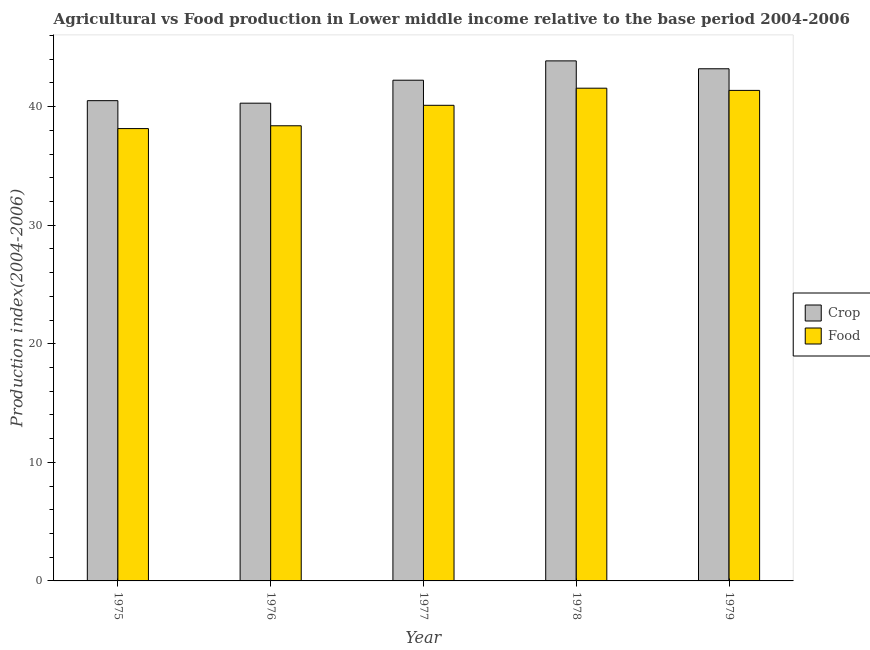How many different coloured bars are there?
Provide a short and direct response. 2. How many groups of bars are there?
Ensure brevity in your answer.  5. Are the number of bars per tick equal to the number of legend labels?
Keep it short and to the point. Yes. How many bars are there on the 1st tick from the right?
Provide a short and direct response. 2. What is the label of the 3rd group of bars from the left?
Your answer should be compact. 1977. In how many cases, is the number of bars for a given year not equal to the number of legend labels?
Keep it short and to the point. 0. What is the food production index in 1975?
Your answer should be very brief. 38.14. Across all years, what is the maximum food production index?
Your answer should be compact. 41.55. Across all years, what is the minimum crop production index?
Your response must be concise. 40.29. In which year was the crop production index maximum?
Ensure brevity in your answer.  1978. In which year was the food production index minimum?
Your answer should be compact. 1975. What is the total food production index in the graph?
Keep it short and to the point. 199.54. What is the difference between the food production index in 1975 and that in 1978?
Make the answer very short. -3.41. What is the difference between the food production index in 1979 and the crop production index in 1977?
Give a very brief answer. 1.26. What is the average food production index per year?
Ensure brevity in your answer.  39.91. In the year 1975, what is the difference between the crop production index and food production index?
Your answer should be compact. 0. In how many years, is the crop production index greater than 36?
Give a very brief answer. 5. What is the ratio of the crop production index in 1977 to that in 1979?
Keep it short and to the point. 0.98. Is the difference between the crop production index in 1975 and 1978 greater than the difference between the food production index in 1975 and 1978?
Your answer should be compact. No. What is the difference between the highest and the second highest crop production index?
Offer a terse response. 0.67. What is the difference between the highest and the lowest food production index?
Provide a short and direct response. 3.41. In how many years, is the crop production index greater than the average crop production index taken over all years?
Your answer should be very brief. 3. What does the 2nd bar from the left in 1977 represents?
Your response must be concise. Food. What does the 1st bar from the right in 1976 represents?
Offer a very short reply. Food. Does the graph contain any zero values?
Offer a terse response. No. Does the graph contain grids?
Provide a short and direct response. No. How many legend labels are there?
Provide a succinct answer. 2. How are the legend labels stacked?
Your answer should be very brief. Vertical. What is the title of the graph?
Ensure brevity in your answer.  Agricultural vs Food production in Lower middle income relative to the base period 2004-2006. Does "Diesel" appear as one of the legend labels in the graph?
Offer a very short reply. No. What is the label or title of the X-axis?
Provide a short and direct response. Year. What is the label or title of the Y-axis?
Provide a succinct answer. Production index(2004-2006). What is the Production index(2004-2006) of Crop in 1975?
Offer a very short reply. 40.5. What is the Production index(2004-2006) in Food in 1975?
Your answer should be very brief. 38.14. What is the Production index(2004-2006) of Crop in 1976?
Give a very brief answer. 40.29. What is the Production index(2004-2006) in Food in 1976?
Provide a short and direct response. 38.38. What is the Production index(2004-2006) in Crop in 1977?
Ensure brevity in your answer.  42.22. What is the Production index(2004-2006) in Food in 1977?
Your answer should be very brief. 40.11. What is the Production index(2004-2006) in Crop in 1978?
Your answer should be very brief. 43.85. What is the Production index(2004-2006) of Food in 1978?
Provide a short and direct response. 41.55. What is the Production index(2004-2006) in Crop in 1979?
Your answer should be very brief. 43.19. What is the Production index(2004-2006) of Food in 1979?
Ensure brevity in your answer.  41.36. Across all years, what is the maximum Production index(2004-2006) of Crop?
Your answer should be compact. 43.85. Across all years, what is the maximum Production index(2004-2006) in Food?
Your answer should be very brief. 41.55. Across all years, what is the minimum Production index(2004-2006) in Crop?
Provide a succinct answer. 40.29. Across all years, what is the minimum Production index(2004-2006) of Food?
Make the answer very short. 38.14. What is the total Production index(2004-2006) in Crop in the graph?
Make the answer very short. 210.05. What is the total Production index(2004-2006) in Food in the graph?
Provide a succinct answer. 199.54. What is the difference between the Production index(2004-2006) in Crop in 1975 and that in 1976?
Your answer should be compact. 0.21. What is the difference between the Production index(2004-2006) of Food in 1975 and that in 1976?
Offer a very short reply. -0.24. What is the difference between the Production index(2004-2006) of Crop in 1975 and that in 1977?
Keep it short and to the point. -1.72. What is the difference between the Production index(2004-2006) of Food in 1975 and that in 1977?
Give a very brief answer. -1.96. What is the difference between the Production index(2004-2006) of Crop in 1975 and that in 1978?
Give a very brief answer. -3.35. What is the difference between the Production index(2004-2006) of Food in 1975 and that in 1978?
Your response must be concise. -3.41. What is the difference between the Production index(2004-2006) in Crop in 1975 and that in 1979?
Your answer should be compact. -2.69. What is the difference between the Production index(2004-2006) of Food in 1975 and that in 1979?
Offer a very short reply. -3.22. What is the difference between the Production index(2004-2006) in Crop in 1976 and that in 1977?
Ensure brevity in your answer.  -1.94. What is the difference between the Production index(2004-2006) in Food in 1976 and that in 1977?
Offer a terse response. -1.73. What is the difference between the Production index(2004-2006) in Crop in 1976 and that in 1978?
Make the answer very short. -3.57. What is the difference between the Production index(2004-2006) in Food in 1976 and that in 1978?
Ensure brevity in your answer.  -3.17. What is the difference between the Production index(2004-2006) of Crop in 1976 and that in 1979?
Your response must be concise. -2.9. What is the difference between the Production index(2004-2006) of Food in 1976 and that in 1979?
Your response must be concise. -2.98. What is the difference between the Production index(2004-2006) of Crop in 1977 and that in 1978?
Provide a succinct answer. -1.63. What is the difference between the Production index(2004-2006) of Food in 1977 and that in 1978?
Ensure brevity in your answer.  -1.44. What is the difference between the Production index(2004-2006) in Crop in 1977 and that in 1979?
Give a very brief answer. -0.96. What is the difference between the Production index(2004-2006) in Food in 1977 and that in 1979?
Your answer should be compact. -1.26. What is the difference between the Production index(2004-2006) of Crop in 1978 and that in 1979?
Your answer should be very brief. 0.67. What is the difference between the Production index(2004-2006) of Food in 1978 and that in 1979?
Give a very brief answer. 0.19. What is the difference between the Production index(2004-2006) in Crop in 1975 and the Production index(2004-2006) in Food in 1976?
Make the answer very short. 2.12. What is the difference between the Production index(2004-2006) of Crop in 1975 and the Production index(2004-2006) of Food in 1977?
Offer a very short reply. 0.39. What is the difference between the Production index(2004-2006) in Crop in 1975 and the Production index(2004-2006) in Food in 1978?
Your answer should be compact. -1.05. What is the difference between the Production index(2004-2006) in Crop in 1975 and the Production index(2004-2006) in Food in 1979?
Provide a short and direct response. -0.86. What is the difference between the Production index(2004-2006) of Crop in 1976 and the Production index(2004-2006) of Food in 1977?
Offer a very short reply. 0.18. What is the difference between the Production index(2004-2006) of Crop in 1976 and the Production index(2004-2006) of Food in 1978?
Offer a terse response. -1.26. What is the difference between the Production index(2004-2006) in Crop in 1976 and the Production index(2004-2006) in Food in 1979?
Provide a short and direct response. -1.08. What is the difference between the Production index(2004-2006) of Crop in 1977 and the Production index(2004-2006) of Food in 1978?
Provide a succinct answer. 0.67. What is the difference between the Production index(2004-2006) of Crop in 1977 and the Production index(2004-2006) of Food in 1979?
Provide a short and direct response. 0.86. What is the difference between the Production index(2004-2006) in Crop in 1978 and the Production index(2004-2006) in Food in 1979?
Offer a very short reply. 2.49. What is the average Production index(2004-2006) of Crop per year?
Offer a terse response. 42.01. What is the average Production index(2004-2006) of Food per year?
Your response must be concise. 39.91. In the year 1975, what is the difference between the Production index(2004-2006) in Crop and Production index(2004-2006) in Food?
Offer a terse response. 2.35. In the year 1976, what is the difference between the Production index(2004-2006) of Crop and Production index(2004-2006) of Food?
Offer a very short reply. 1.91. In the year 1977, what is the difference between the Production index(2004-2006) of Crop and Production index(2004-2006) of Food?
Make the answer very short. 2.12. In the year 1978, what is the difference between the Production index(2004-2006) in Crop and Production index(2004-2006) in Food?
Keep it short and to the point. 2.3. In the year 1979, what is the difference between the Production index(2004-2006) in Crop and Production index(2004-2006) in Food?
Offer a very short reply. 1.82. What is the ratio of the Production index(2004-2006) in Crop in 1975 to that in 1976?
Your response must be concise. 1.01. What is the ratio of the Production index(2004-2006) of Crop in 1975 to that in 1977?
Your response must be concise. 0.96. What is the ratio of the Production index(2004-2006) in Food in 1975 to that in 1977?
Ensure brevity in your answer.  0.95. What is the ratio of the Production index(2004-2006) in Crop in 1975 to that in 1978?
Offer a terse response. 0.92. What is the ratio of the Production index(2004-2006) in Food in 1975 to that in 1978?
Your response must be concise. 0.92. What is the ratio of the Production index(2004-2006) of Crop in 1975 to that in 1979?
Keep it short and to the point. 0.94. What is the ratio of the Production index(2004-2006) of Food in 1975 to that in 1979?
Offer a terse response. 0.92. What is the ratio of the Production index(2004-2006) in Crop in 1976 to that in 1977?
Keep it short and to the point. 0.95. What is the ratio of the Production index(2004-2006) in Crop in 1976 to that in 1978?
Make the answer very short. 0.92. What is the ratio of the Production index(2004-2006) of Food in 1976 to that in 1978?
Provide a succinct answer. 0.92. What is the ratio of the Production index(2004-2006) in Crop in 1976 to that in 1979?
Your answer should be very brief. 0.93. What is the ratio of the Production index(2004-2006) in Food in 1976 to that in 1979?
Ensure brevity in your answer.  0.93. What is the ratio of the Production index(2004-2006) of Crop in 1977 to that in 1978?
Offer a very short reply. 0.96. What is the ratio of the Production index(2004-2006) in Food in 1977 to that in 1978?
Your answer should be compact. 0.97. What is the ratio of the Production index(2004-2006) of Crop in 1977 to that in 1979?
Make the answer very short. 0.98. What is the ratio of the Production index(2004-2006) in Food in 1977 to that in 1979?
Make the answer very short. 0.97. What is the ratio of the Production index(2004-2006) in Crop in 1978 to that in 1979?
Give a very brief answer. 1.02. What is the difference between the highest and the second highest Production index(2004-2006) in Crop?
Give a very brief answer. 0.67. What is the difference between the highest and the second highest Production index(2004-2006) of Food?
Provide a succinct answer. 0.19. What is the difference between the highest and the lowest Production index(2004-2006) in Crop?
Your response must be concise. 3.57. What is the difference between the highest and the lowest Production index(2004-2006) in Food?
Make the answer very short. 3.41. 